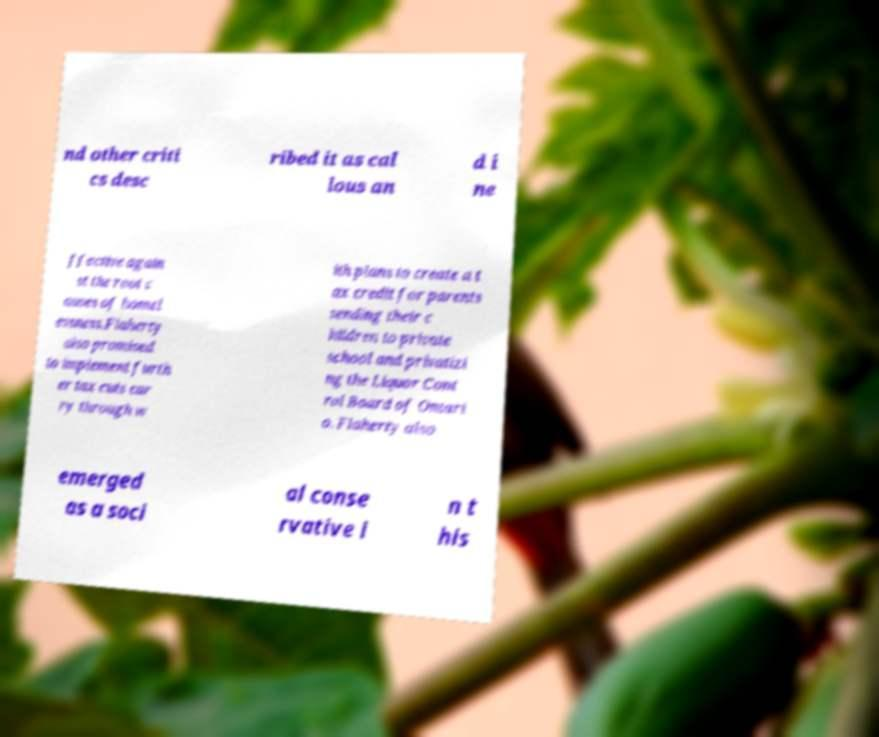Please identify and transcribe the text found in this image. nd other criti cs desc ribed it as cal lous an d i ne ffective again st the root c auses of homel essness.Flaherty also promised to implement furth er tax cuts car ry through w ith plans to create a t ax credit for parents sending their c hildren to private school and privatizi ng the Liquor Cont rol Board of Ontari o. Flaherty also emerged as a soci al conse rvative i n t his 